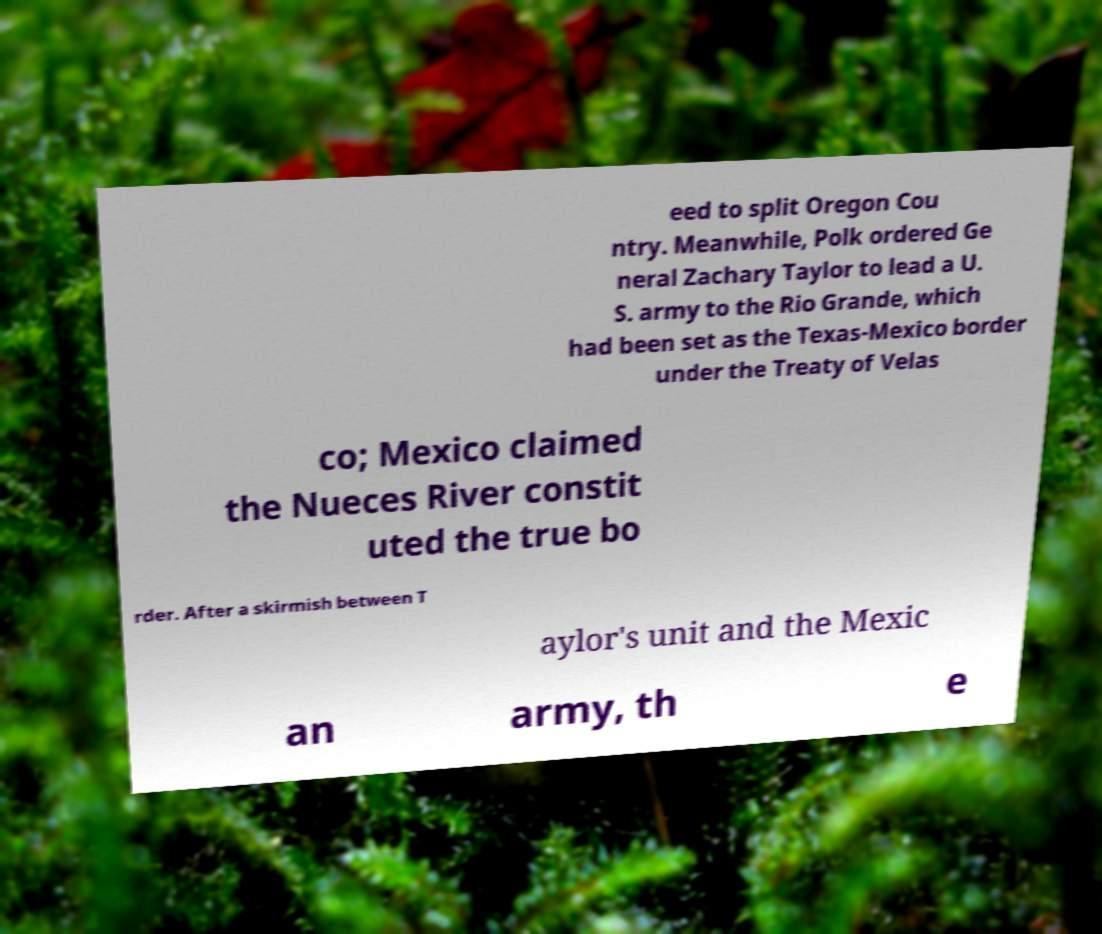There's text embedded in this image that I need extracted. Can you transcribe it verbatim? eed to split Oregon Cou ntry. Meanwhile, Polk ordered Ge neral Zachary Taylor to lead a U. S. army to the Rio Grande, which had been set as the Texas-Mexico border under the Treaty of Velas co; Mexico claimed the Nueces River constit uted the true bo rder. After a skirmish between T aylor's unit and the Mexic an army, th e 